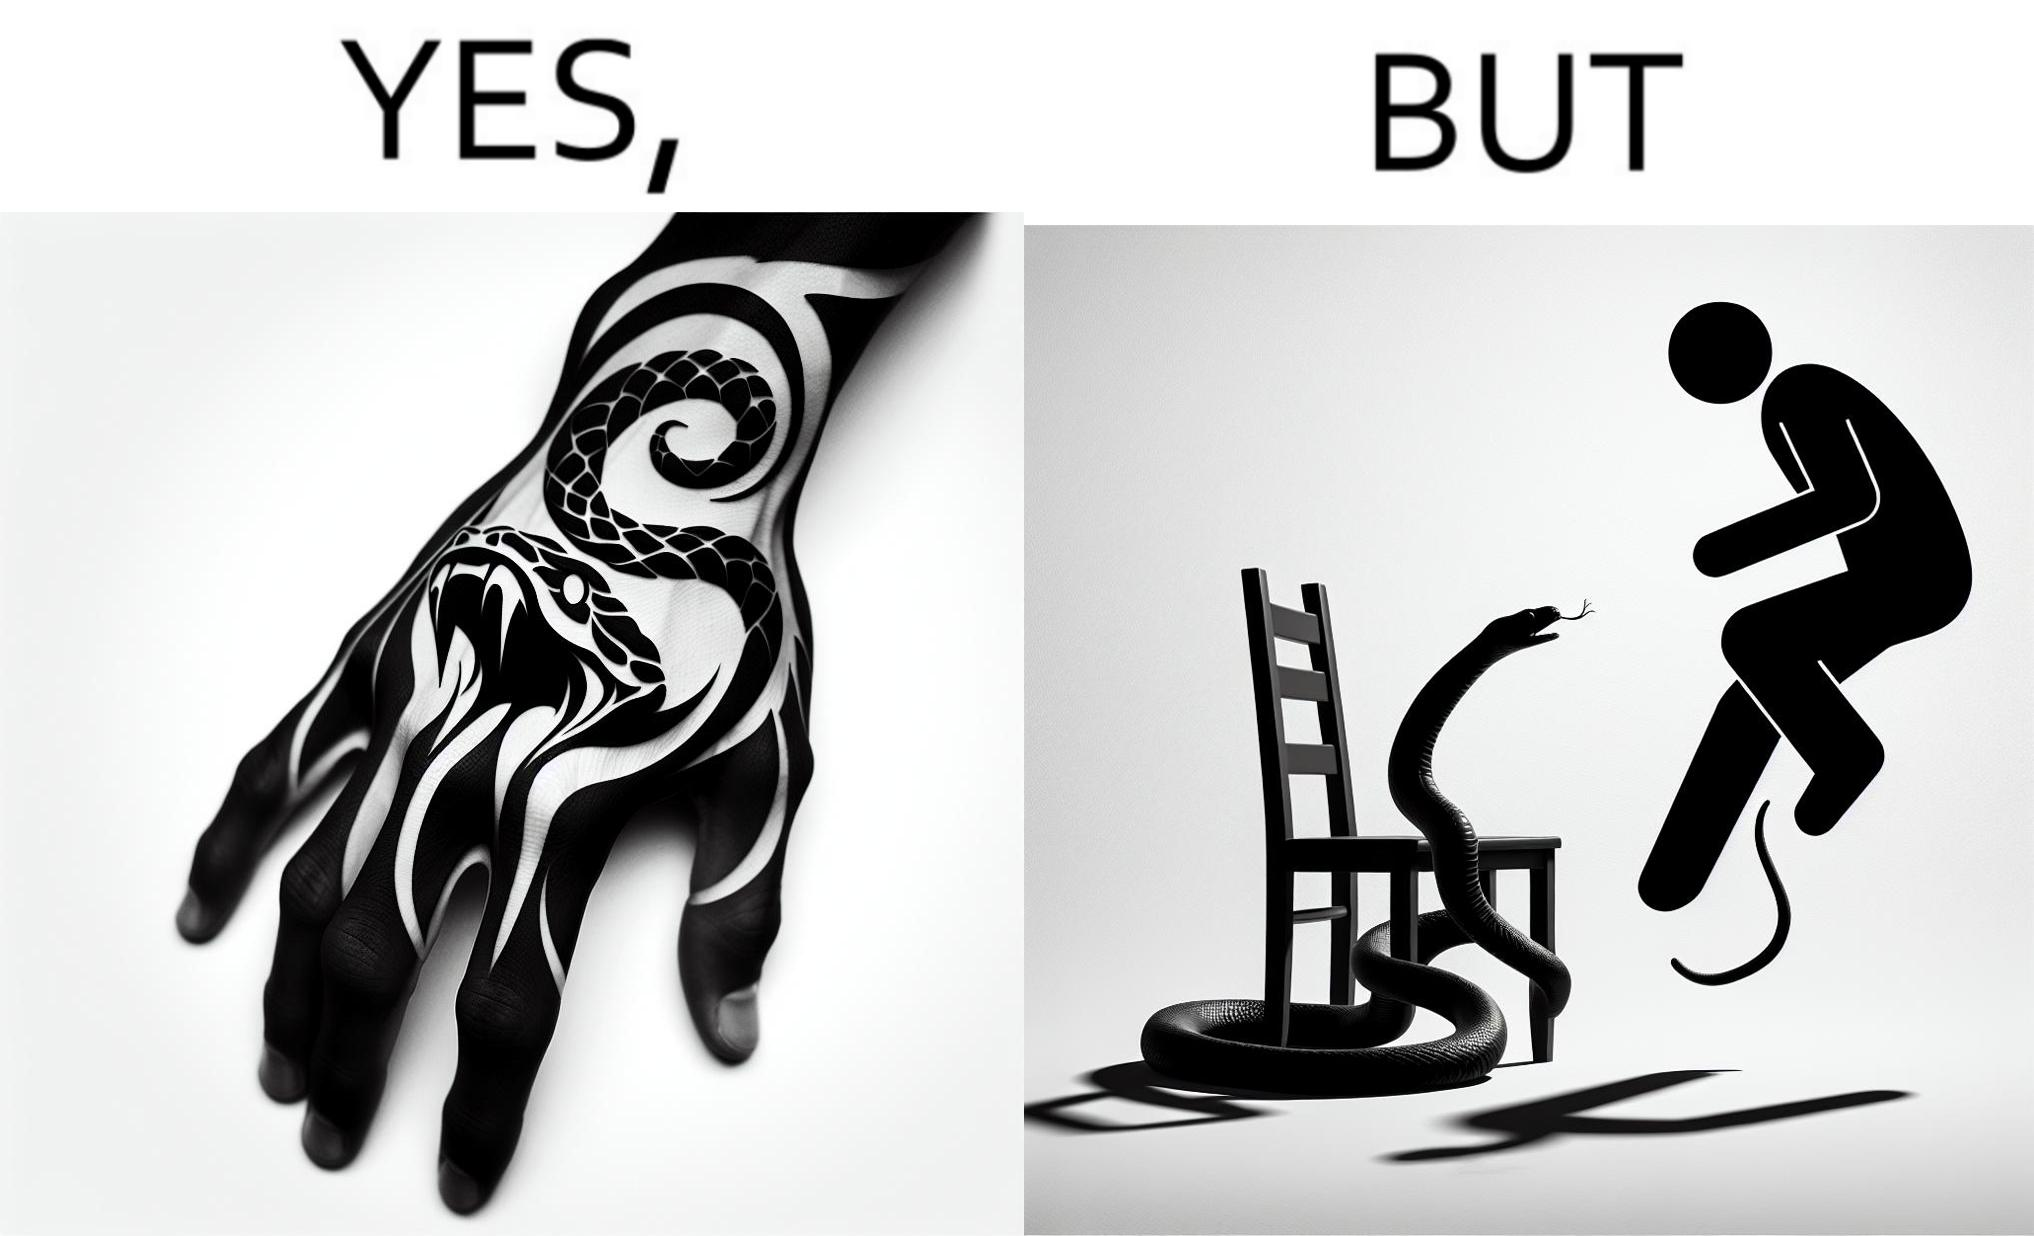Explain the humor or irony in this image. The image is ironic, because in the first image the tattoo of a snake on someone's hand may give us a hint about how powerful or brave the person can be who is having this tattoo but in the second image the person with same tattoo is seen frightened due to a snake in his house 